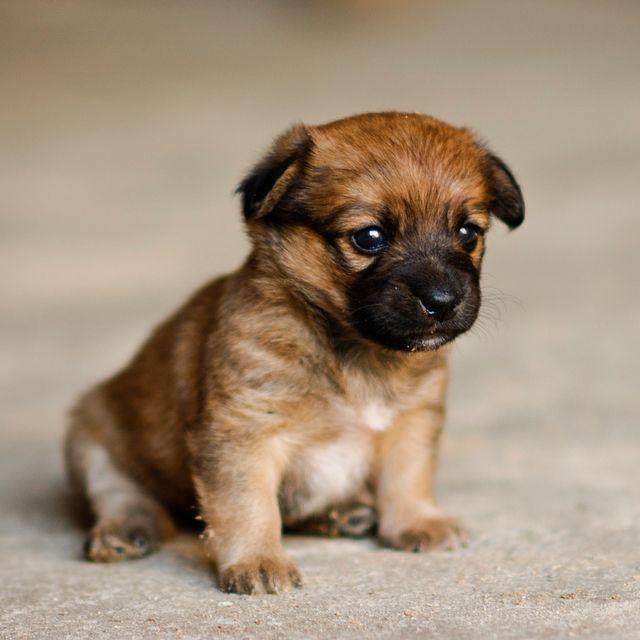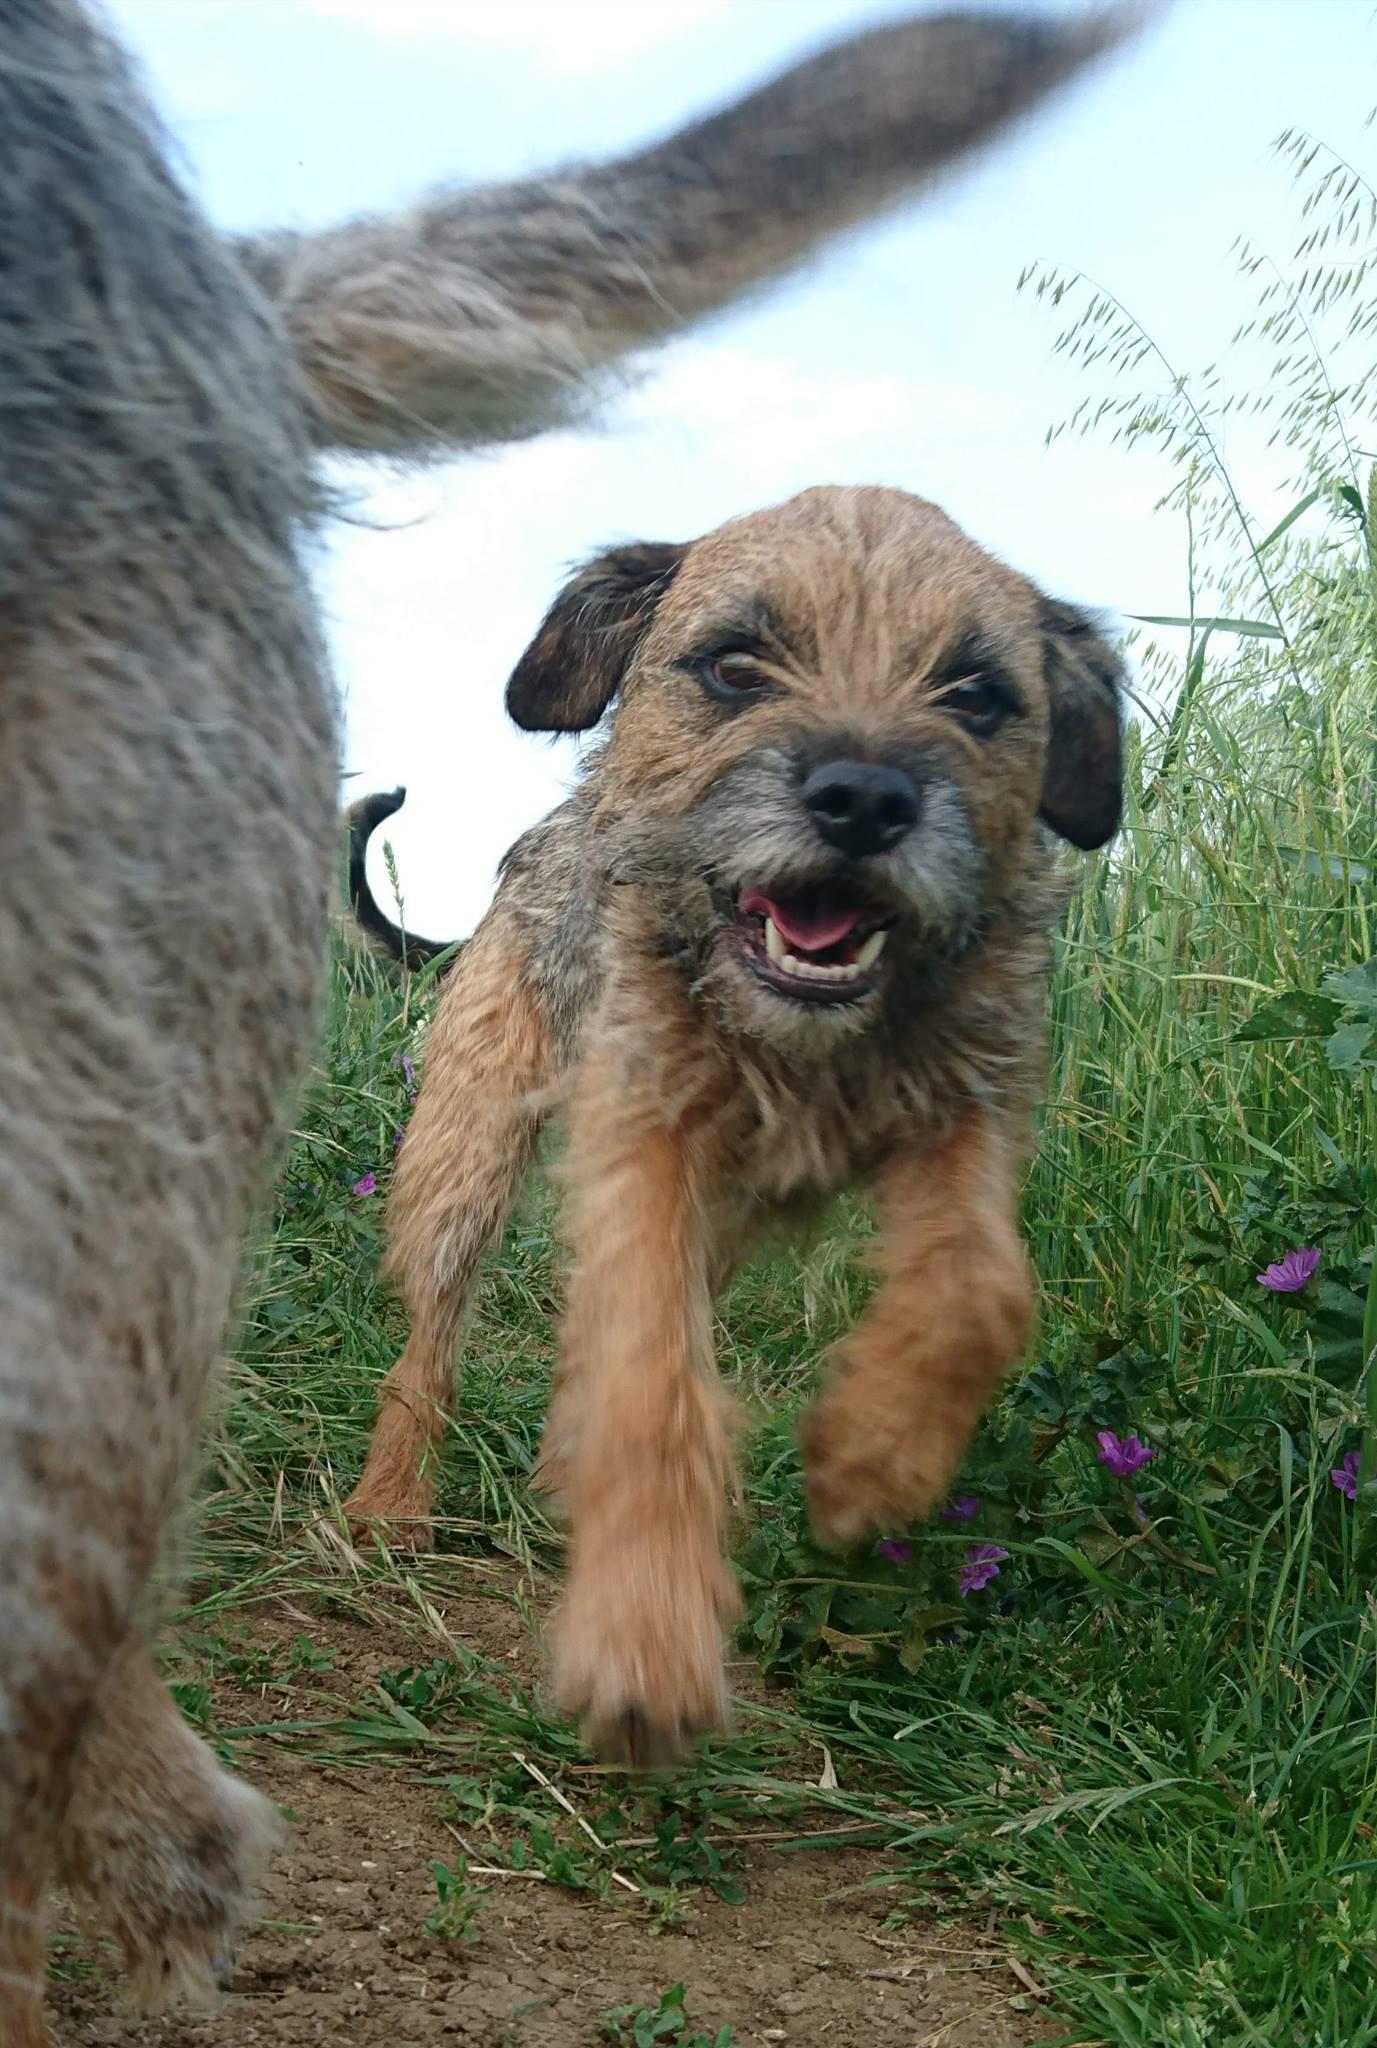The first image is the image on the left, the second image is the image on the right. Evaluate the accuracy of this statement regarding the images: "The left and right image contains the same number of dogs with at least one sitting.". Is it true? Answer yes or no. Yes. The first image is the image on the left, the second image is the image on the right. Evaluate the accuracy of this statement regarding the images: "There are exactly two puppies, one in each image, and both of their faces are visible.". Is it true? Answer yes or no. Yes. 